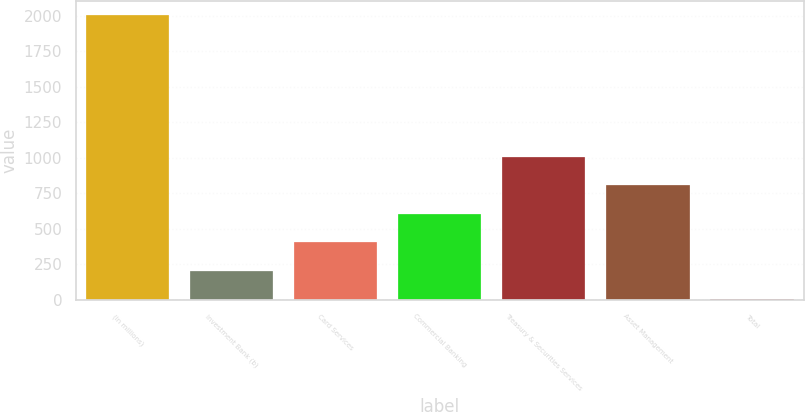Convert chart. <chart><loc_0><loc_0><loc_500><loc_500><bar_chart><fcel>(in millions)<fcel>Investment Bank (b)<fcel>Card Services<fcel>Commercial Banking<fcel>Treasury & Securities Services<fcel>Asset Management<fcel>Total<nl><fcel>2008<fcel>204.4<fcel>404.8<fcel>605.2<fcel>1006<fcel>805.6<fcel>4<nl></chart> 